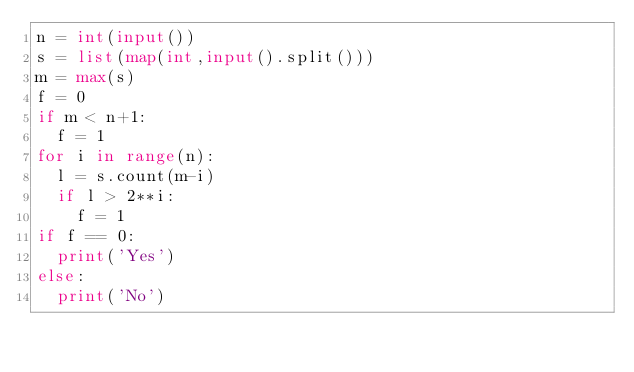<code> <loc_0><loc_0><loc_500><loc_500><_Python_>n = int(input())
s = list(map(int,input().split()))
m = max(s)
f = 0
if m < n+1:
  f = 1
for i in range(n):
  l = s.count(m-i)
  if l > 2**i:
    f = 1
if f == 0:
  print('Yes')
else:
  print('No')
</code> 